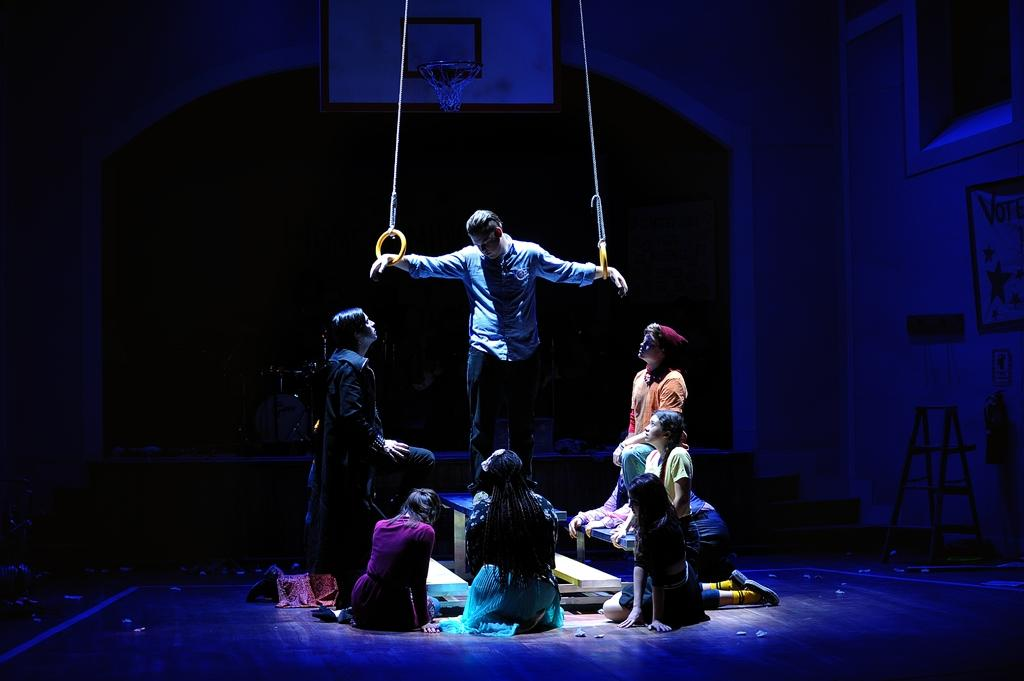What is happening on the stage in the image? There are people playing an act on the stage. What can be seen behind the people on the stage? There is a basket behind the people on the stage. How would you describe the lighting in the image? The background of the image is dark. What type of celery can be seen growing in the field behind the stage? There is no field or celery present in the image; it features a stage with people performing an act and a basket in the background. 